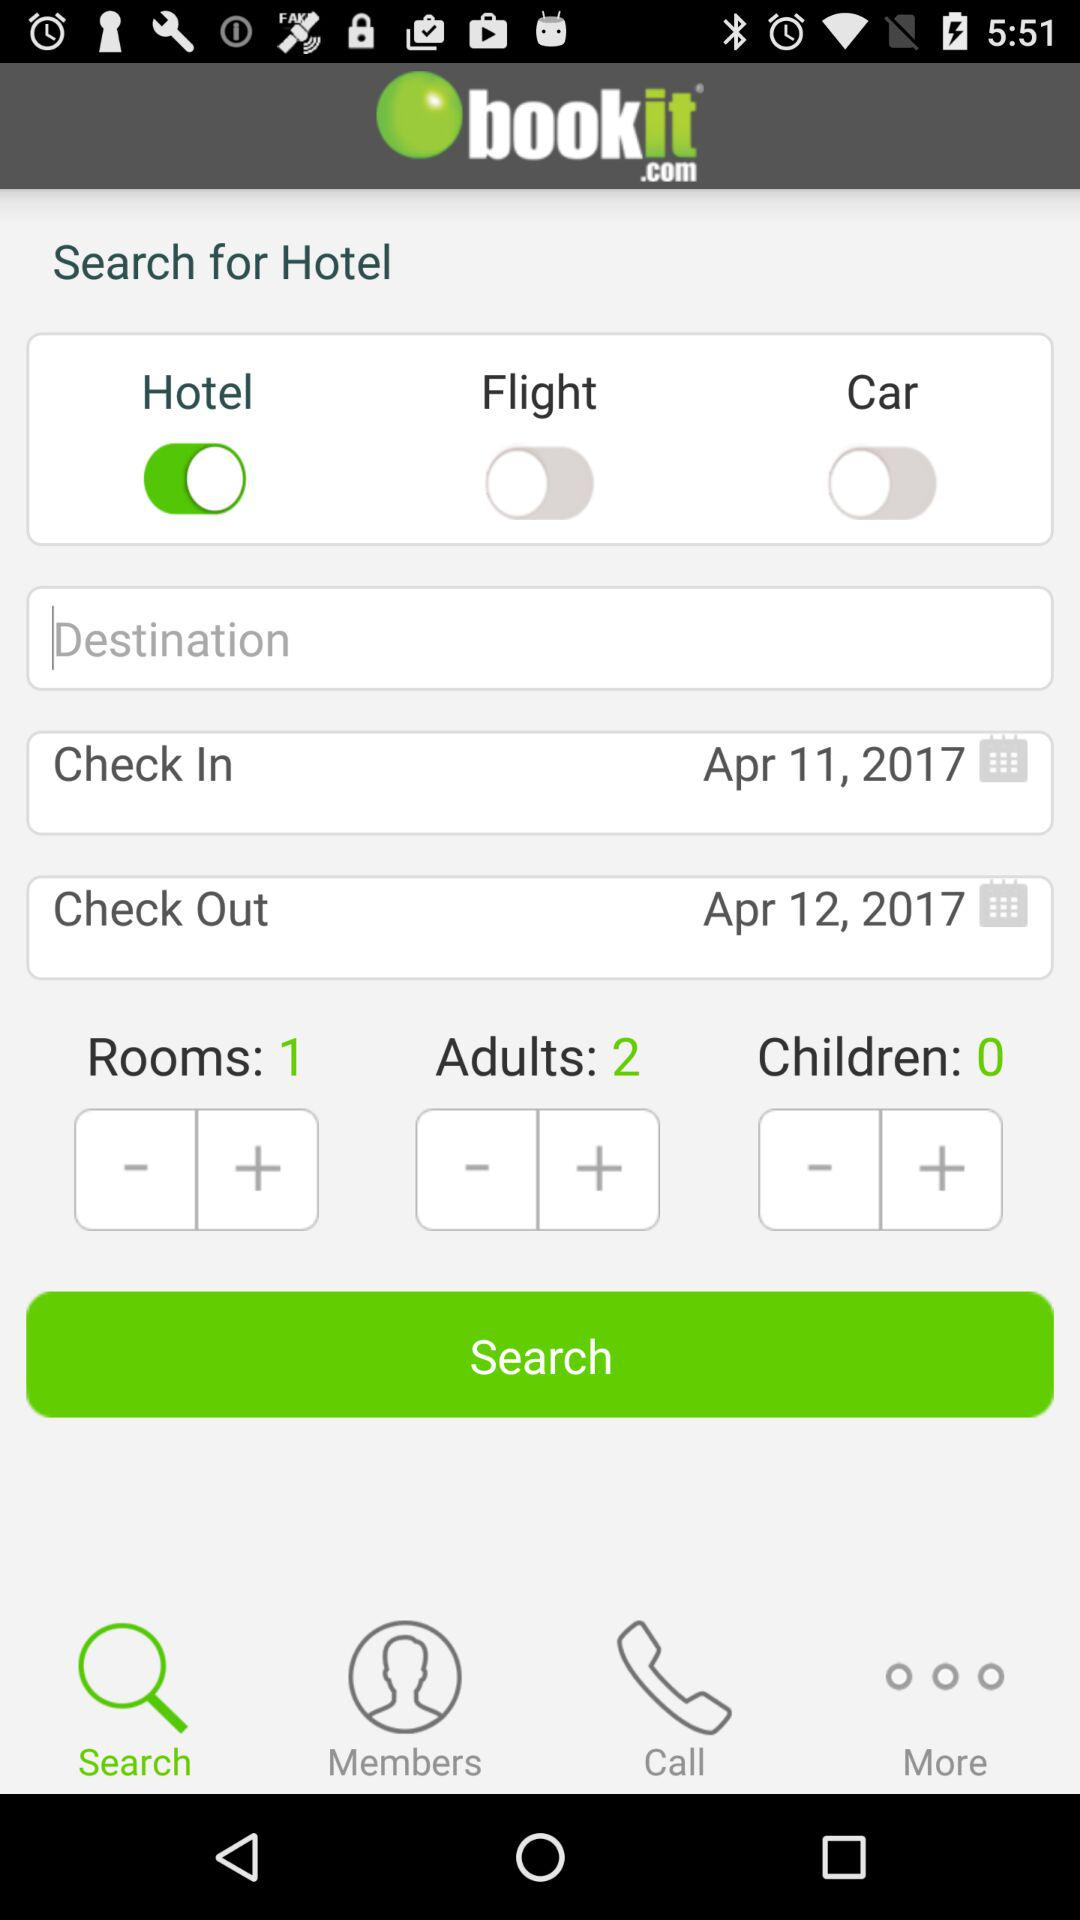What is the check in date? The check in date is April 11, 2017. 